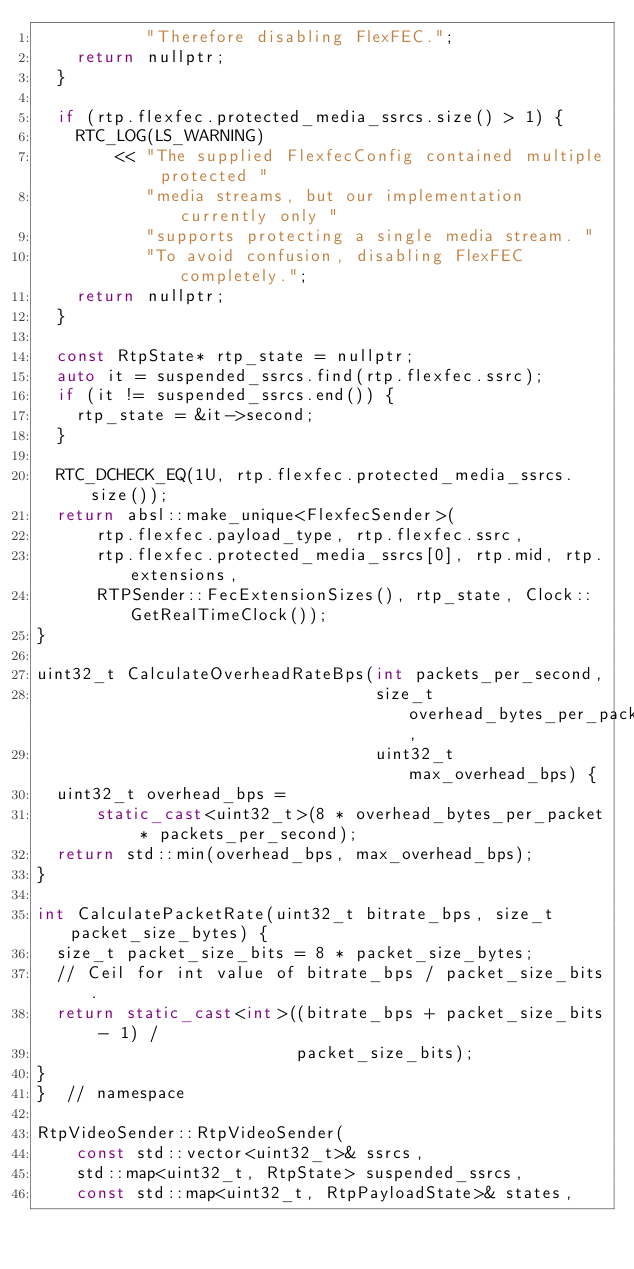Convert code to text. <code><loc_0><loc_0><loc_500><loc_500><_C++_>           "Therefore disabling FlexFEC.";
    return nullptr;
  }

  if (rtp.flexfec.protected_media_ssrcs.size() > 1) {
    RTC_LOG(LS_WARNING)
        << "The supplied FlexfecConfig contained multiple protected "
           "media streams, but our implementation currently only "
           "supports protecting a single media stream. "
           "To avoid confusion, disabling FlexFEC completely.";
    return nullptr;
  }

  const RtpState* rtp_state = nullptr;
  auto it = suspended_ssrcs.find(rtp.flexfec.ssrc);
  if (it != suspended_ssrcs.end()) {
    rtp_state = &it->second;
  }

  RTC_DCHECK_EQ(1U, rtp.flexfec.protected_media_ssrcs.size());
  return absl::make_unique<FlexfecSender>(
      rtp.flexfec.payload_type, rtp.flexfec.ssrc,
      rtp.flexfec.protected_media_ssrcs[0], rtp.mid, rtp.extensions,
      RTPSender::FecExtensionSizes(), rtp_state, Clock::GetRealTimeClock());
}

uint32_t CalculateOverheadRateBps(int packets_per_second,
                                  size_t overhead_bytes_per_packet,
                                  uint32_t max_overhead_bps) {
  uint32_t overhead_bps =
      static_cast<uint32_t>(8 * overhead_bytes_per_packet * packets_per_second);
  return std::min(overhead_bps, max_overhead_bps);
}

int CalculatePacketRate(uint32_t bitrate_bps, size_t packet_size_bytes) {
  size_t packet_size_bits = 8 * packet_size_bytes;
  // Ceil for int value of bitrate_bps / packet_size_bits.
  return static_cast<int>((bitrate_bps + packet_size_bits - 1) /
                          packet_size_bits);
}
}  // namespace

RtpVideoSender::RtpVideoSender(
    const std::vector<uint32_t>& ssrcs,
    std::map<uint32_t, RtpState> suspended_ssrcs,
    const std::map<uint32_t, RtpPayloadState>& states,</code> 